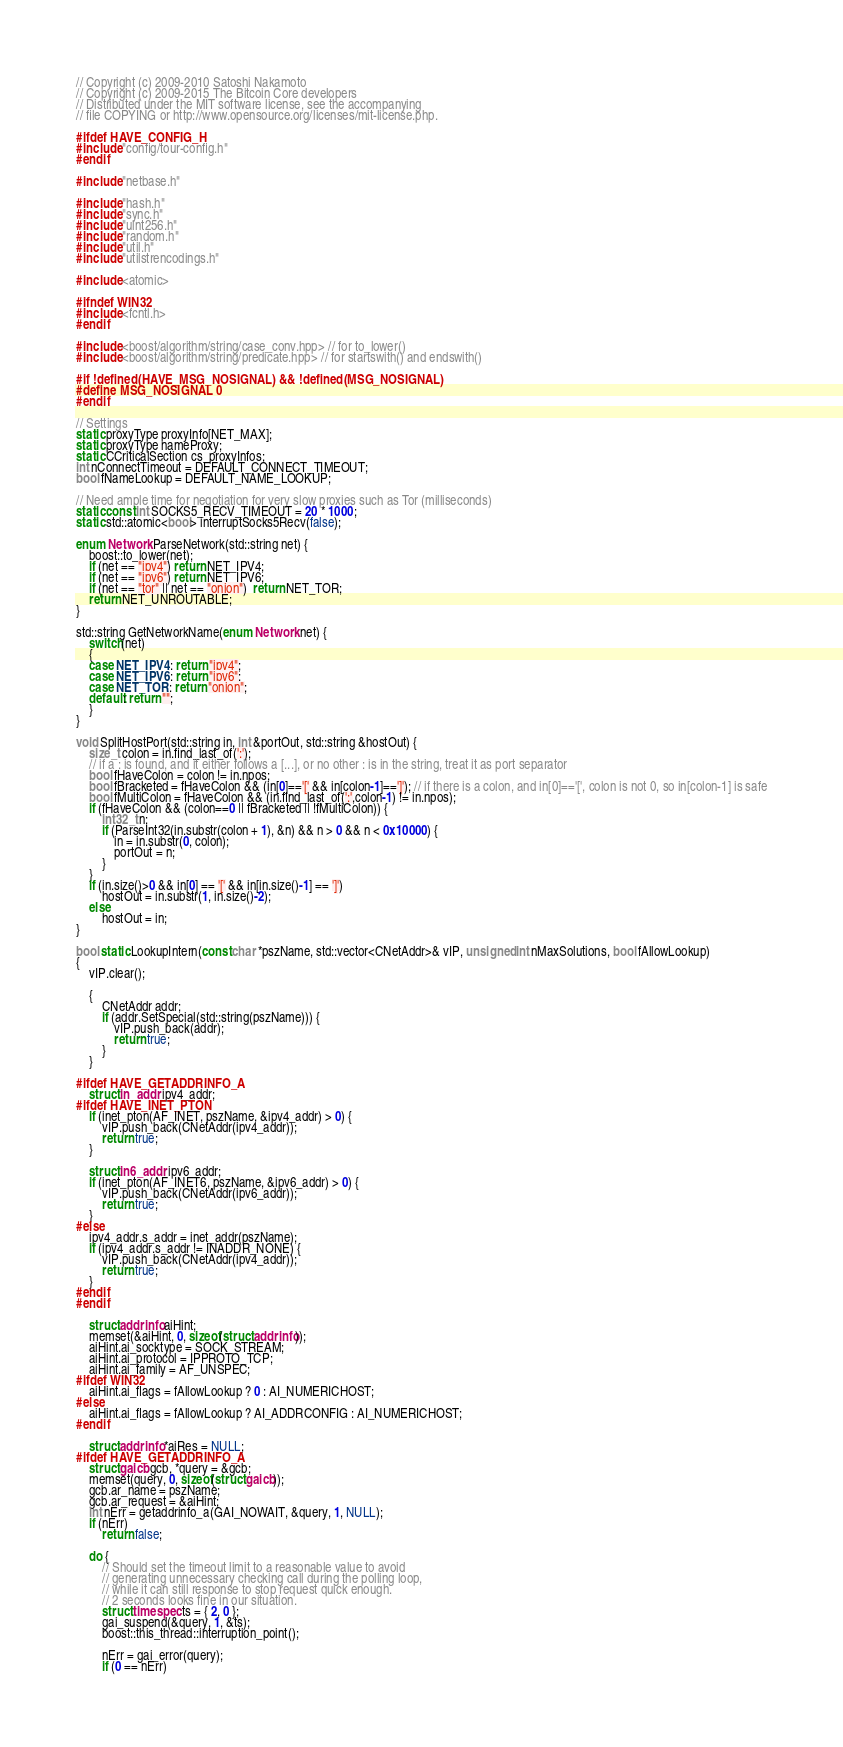<code> <loc_0><loc_0><loc_500><loc_500><_C++_>// Copyright (c) 2009-2010 Satoshi Nakamoto
// Copyright (c) 2009-2015 The Bitcoin Core developers
// Distributed under the MIT software license, see the accompanying
// file COPYING or http://www.opensource.org/licenses/mit-license.php.

#ifdef HAVE_CONFIG_H
#include "config/tour-config.h"
#endif

#include "netbase.h"

#include "hash.h"
#include "sync.h"
#include "uint256.h"
#include "random.h"
#include "util.h"
#include "utilstrencodings.h"

#include <atomic>

#ifndef WIN32
#include <fcntl.h>
#endif

#include <boost/algorithm/string/case_conv.hpp> // for to_lower()
#include <boost/algorithm/string/predicate.hpp> // for startswith() and endswith()

#if !defined(HAVE_MSG_NOSIGNAL) && !defined(MSG_NOSIGNAL)
#define MSG_NOSIGNAL 0
#endif

// Settings
static proxyType proxyInfo[NET_MAX];
static proxyType nameProxy;
static CCriticalSection cs_proxyInfos;
int nConnectTimeout = DEFAULT_CONNECT_TIMEOUT;
bool fNameLookup = DEFAULT_NAME_LOOKUP;

// Need ample time for negotiation for very slow proxies such as Tor (milliseconds)
static const int SOCKS5_RECV_TIMEOUT = 20 * 1000;
static std::atomic<bool> interruptSocks5Recv(false);

enum Network ParseNetwork(std::string net) {
    boost::to_lower(net);
    if (net == "ipv4") return NET_IPV4;
    if (net == "ipv6") return NET_IPV6;
    if (net == "tor" || net == "onion")  return NET_TOR;
    return NET_UNROUTABLE;
}

std::string GetNetworkName(enum Network net) {
    switch(net)
    {
    case NET_IPV4: return "ipv4";
    case NET_IPV6: return "ipv6";
    case NET_TOR: return "onion";
    default: return "";
    }
}

void SplitHostPort(std::string in, int &portOut, std::string &hostOut) {
    size_t colon = in.find_last_of(':');
    // if a : is found, and it either follows a [...], or no other : is in the string, treat it as port separator
    bool fHaveColon = colon != in.npos;
    bool fBracketed = fHaveColon && (in[0]=='[' && in[colon-1]==']'); // if there is a colon, and in[0]=='[', colon is not 0, so in[colon-1] is safe
    bool fMultiColon = fHaveColon && (in.find_last_of(':',colon-1) != in.npos);
    if (fHaveColon && (colon==0 || fBracketed || !fMultiColon)) {
        int32_t n;
        if (ParseInt32(in.substr(colon + 1), &n) && n > 0 && n < 0x10000) {
            in = in.substr(0, colon);
            portOut = n;
        }
    }
    if (in.size()>0 && in[0] == '[' && in[in.size()-1] == ']')
        hostOut = in.substr(1, in.size()-2);
    else
        hostOut = in;
}

bool static LookupIntern(const char *pszName, std::vector<CNetAddr>& vIP, unsigned int nMaxSolutions, bool fAllowLookup)
{
    vIP.clear();

    {
        CNetAddr addr;
        if (addr.SetSpecial(std::string(pszName))) {
            vIP.push_back(addr);
            return true;
        }
    }

#ifdef HAVE_GETADDRINFO_A
    struct in_addr ipv4_addr;
#ifdef HAVE_INET_PTON
    if (inet_pton(AF_INET, pszName, &ipv4_addr) > 0) {
        vIP.push_back(CNetAddr(ipv4_addr));
        return true;
    }

    struct in6_addr ipv6_addr;
    if (inet_pton(AF_INET6, pszName, &ipv6_addr) > 0) {
        vIP.push_back(CNetAddr(ipv6_addr));
        return true;
    }
#else
    ipv4_addr.s_addr = inet_addr(pszName);
    if (ipv4_addr.s_addr != INADDR_NONE) {
        vIP.push_back(CNetAddr(ipv4_addr));
        return true;
    }
#endif
#endif

    struct addrinfo aiHint;
    memset(&aiHint, 0, sizeof(struct addrinfo));
    aiHint.ai_socktype = SOCK_STREAM;
    aiHint.ai_protocol = IPPROTO_TCP;
    aiHint.ai_family = AF_UNSPEC;
#ifdef WIN32
    aiHint.ai_flags = fAllowLookup ? 0 : AI_NUMERICHOST;
#else
    aiHint.ai_flags = fAllowLookup ? AI_ADDRCONFIG : AI_NUMERICHOST;
#endif

    struct addrinfo *aiRes = NULL;
#ifdef HAVE_GETADDRINFO_A
    struct gaicb gcb, *query = &gcb;
    memset(query, 0, sizeof(struct gaicb));
    gcb.ar_name = pszName;
    gcb.ar_request = &aiHint;
    int nErr = getaddrinfo_a(GAI_NOWAIT, &query, 1, NULL);
    if (nErr)
        return false;

    do {
        // Should set the timeout limit to a reasonable value to avoid
        // generating unnecessary checking call during the polling loop,
        // while it can still response to stop request quick enough.
        // 2 seconds looks fine in our situation.
        struct timespec ts = { 2, 0 };
        gai_suspend(&query, 1, &ts);
        boost::this_thread::interruption_point();

        nErr = gai_error(query);
        if (0 == nErr)</code> 